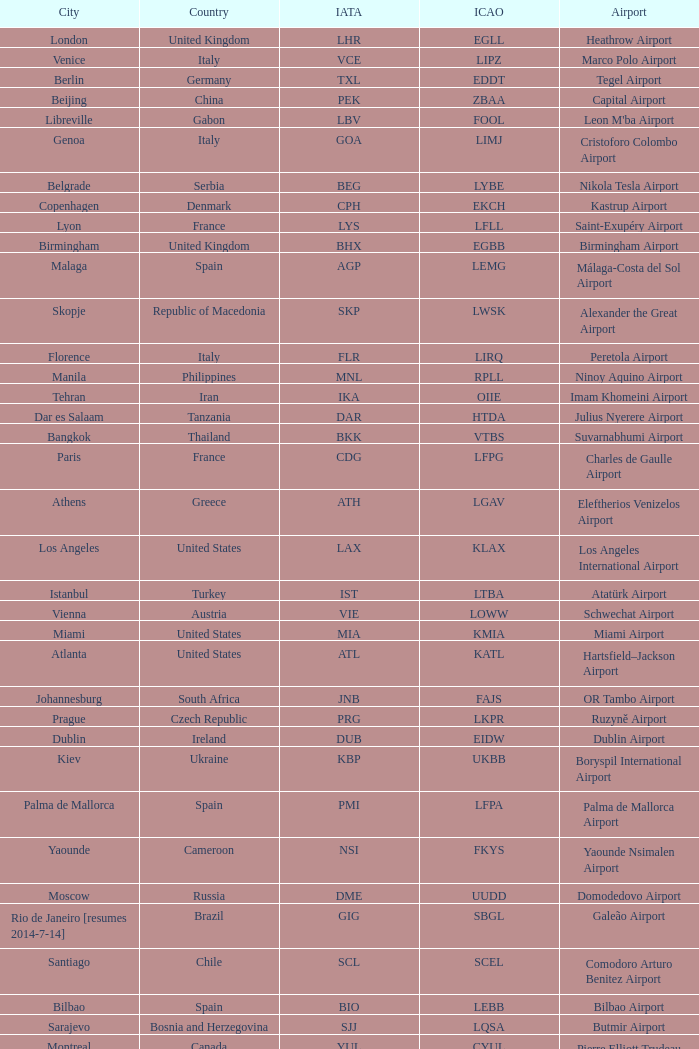What city is fuhlsbüttel airport in? Hamburg. 